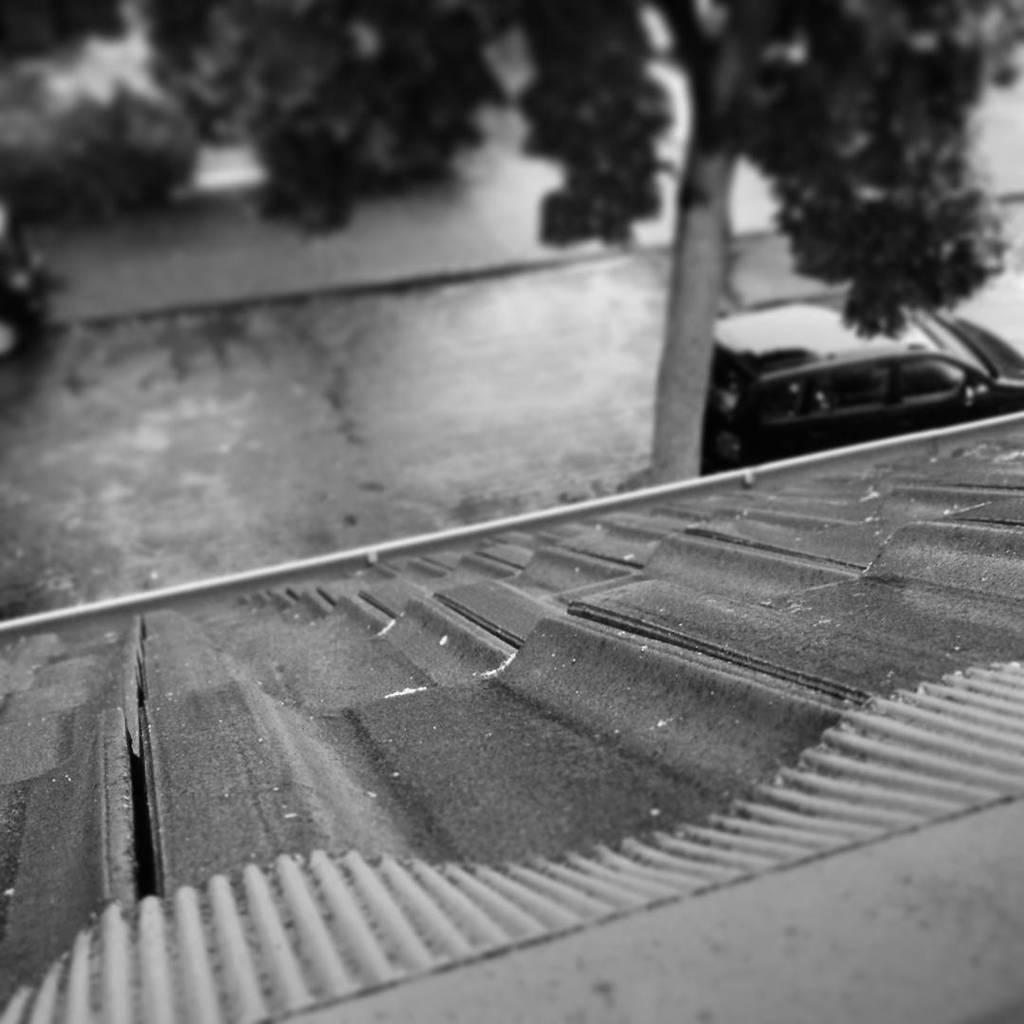What type of structure is visible in the image? The image contains a roof, which suggests a building or house. What is located in front of the roof? There is a road in front of the roof. What can be seen to the right of the roof? There is a car to the right of the roof. What is located to the right of the car? There is a tree to the right of the car. How is the image presented in terms of color? The image is in black and white. How many friends are sitting on the roof in the image? There are no friends visible on the roof in the image, as it only shows the roof, a road, a car, and a tree. 